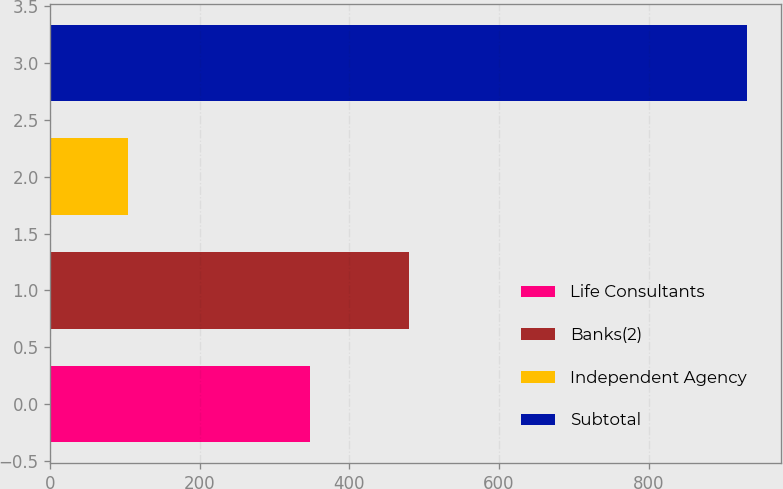Convert chart. <chart><loc_0><loc_0><loc_500><loc_500><bar_chart><fcel>Life Consultants<fcel>Banks(2)<fcel>Independent Agency<fcel>Subtotal<nl><fcel>347<fcel>480<fcel>104<fcel>931<nl></chart> 